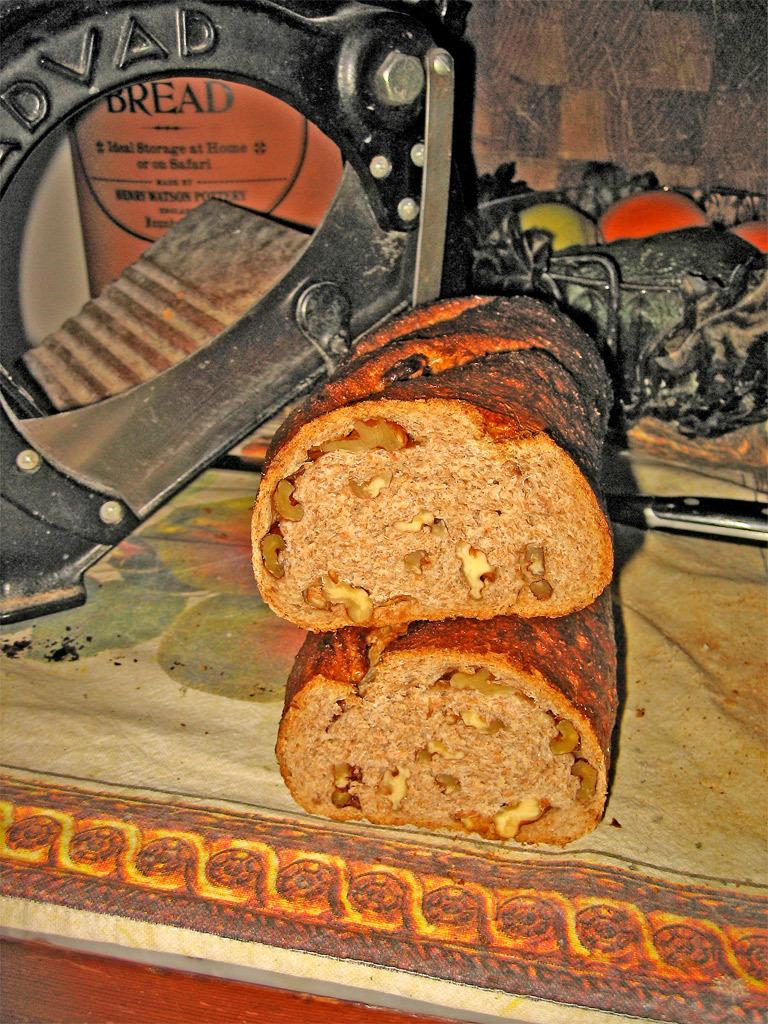What is present on the surface in the image? There is food on a surface in the image. What can be seen in the background of the image? There is a bowl, a wall, and other objects in the background of the image. Can you describe the object at the bottom of the image? There is an object at the bottom of the image, but its specific details are not clear from the provided facts. What type of skin can be seen on the thumb in the image? There is no thumb or skin present in the image. What is inside the sack that is visible in the image? There is no sack present in the image. 